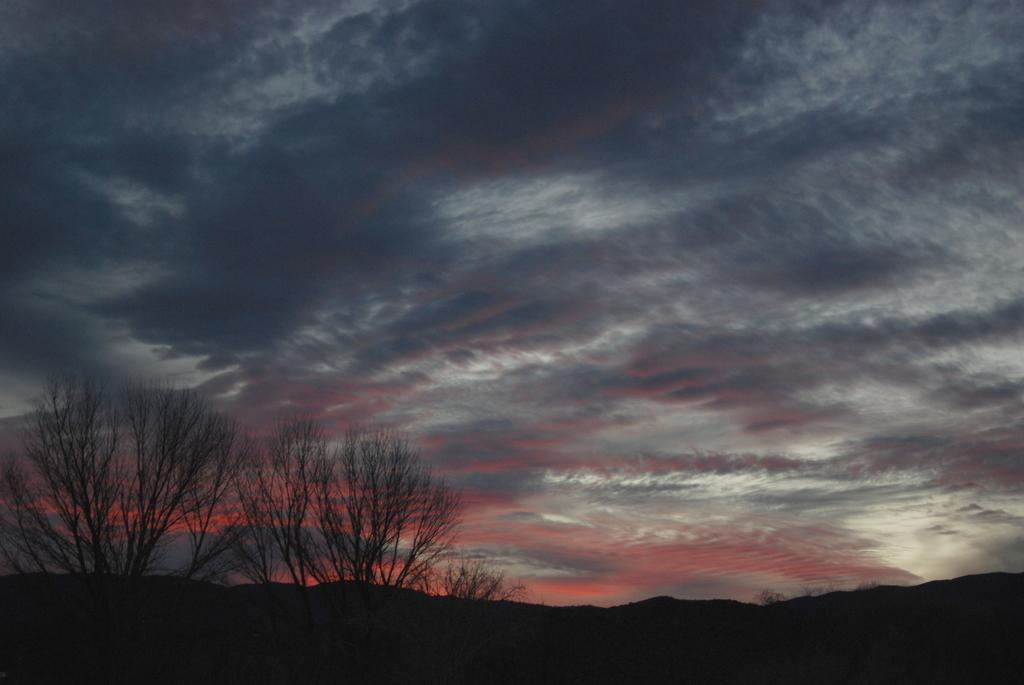What type of vegetation can be seen in the foreground of the image? There are trees in the foreground of the image. What part of the natural environment is visible in the background of the image? The sky is visible in the background of the image. How many cars are parked under the trees in the image? There are no cars present in the image; it only features trees in the foreground and the sky in the background. What type of pin can be seen holding the trees together in the image? There is no pin present in the image; the trees are not held together by any visible object. 